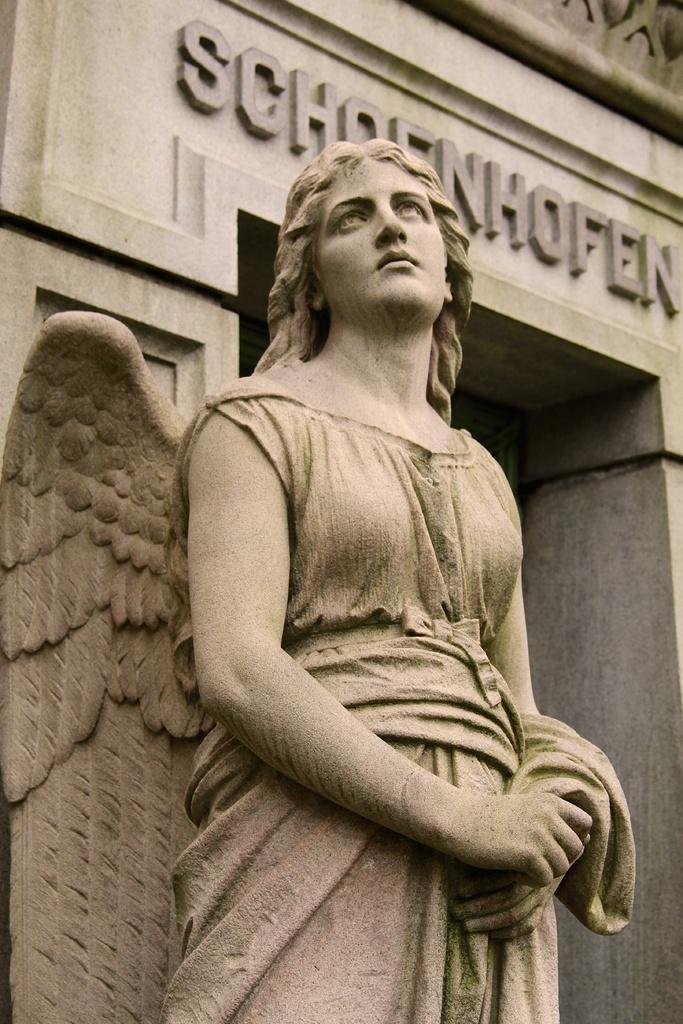What is the main subject of the image? There is a statue of a woman in the image. What can be seen in the background of the image? There is a building in the background of the image. Is there any text visible in the image? Yes, there is some text on a wall in the image. How does the baby show respect to the statue in the image? There is no baby present in the image, so it is not possible to answer that question. 